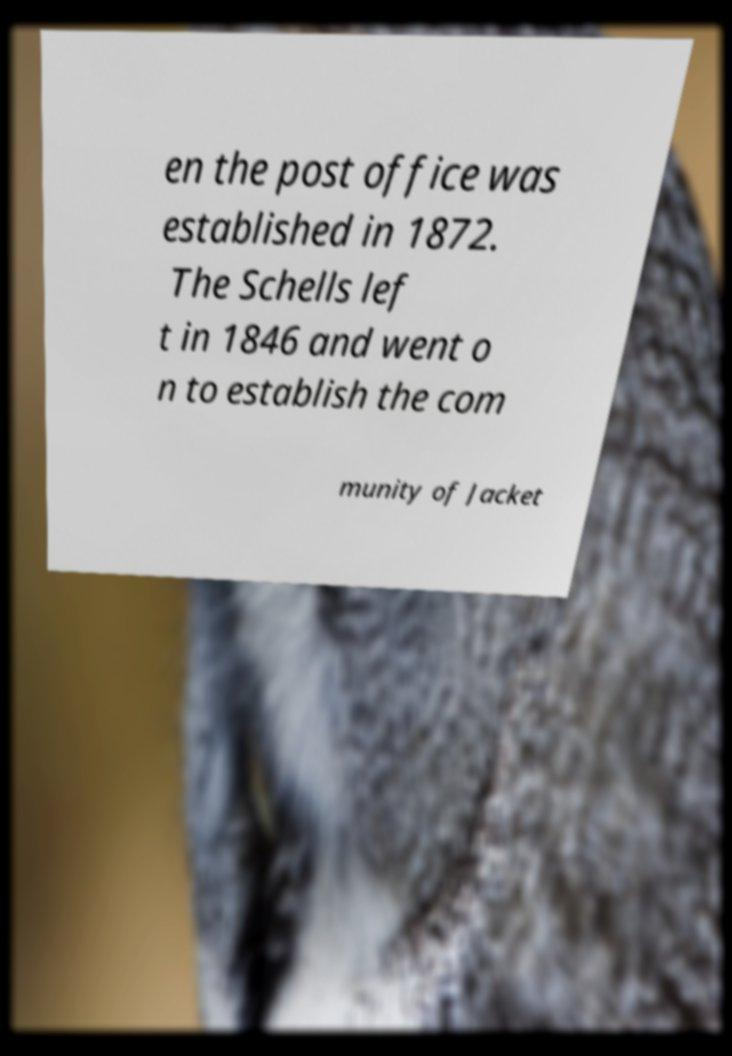There's text embedded in this image that I need extracted. Can you transcribe it verbatim? en the post office was established in 1872. The Schells lef t in 1846 and went o n to establish the com munity of Jacket 